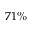<formula> <loc_0><loc_0><loc_500><loc_500>7 1 \%</formula> 